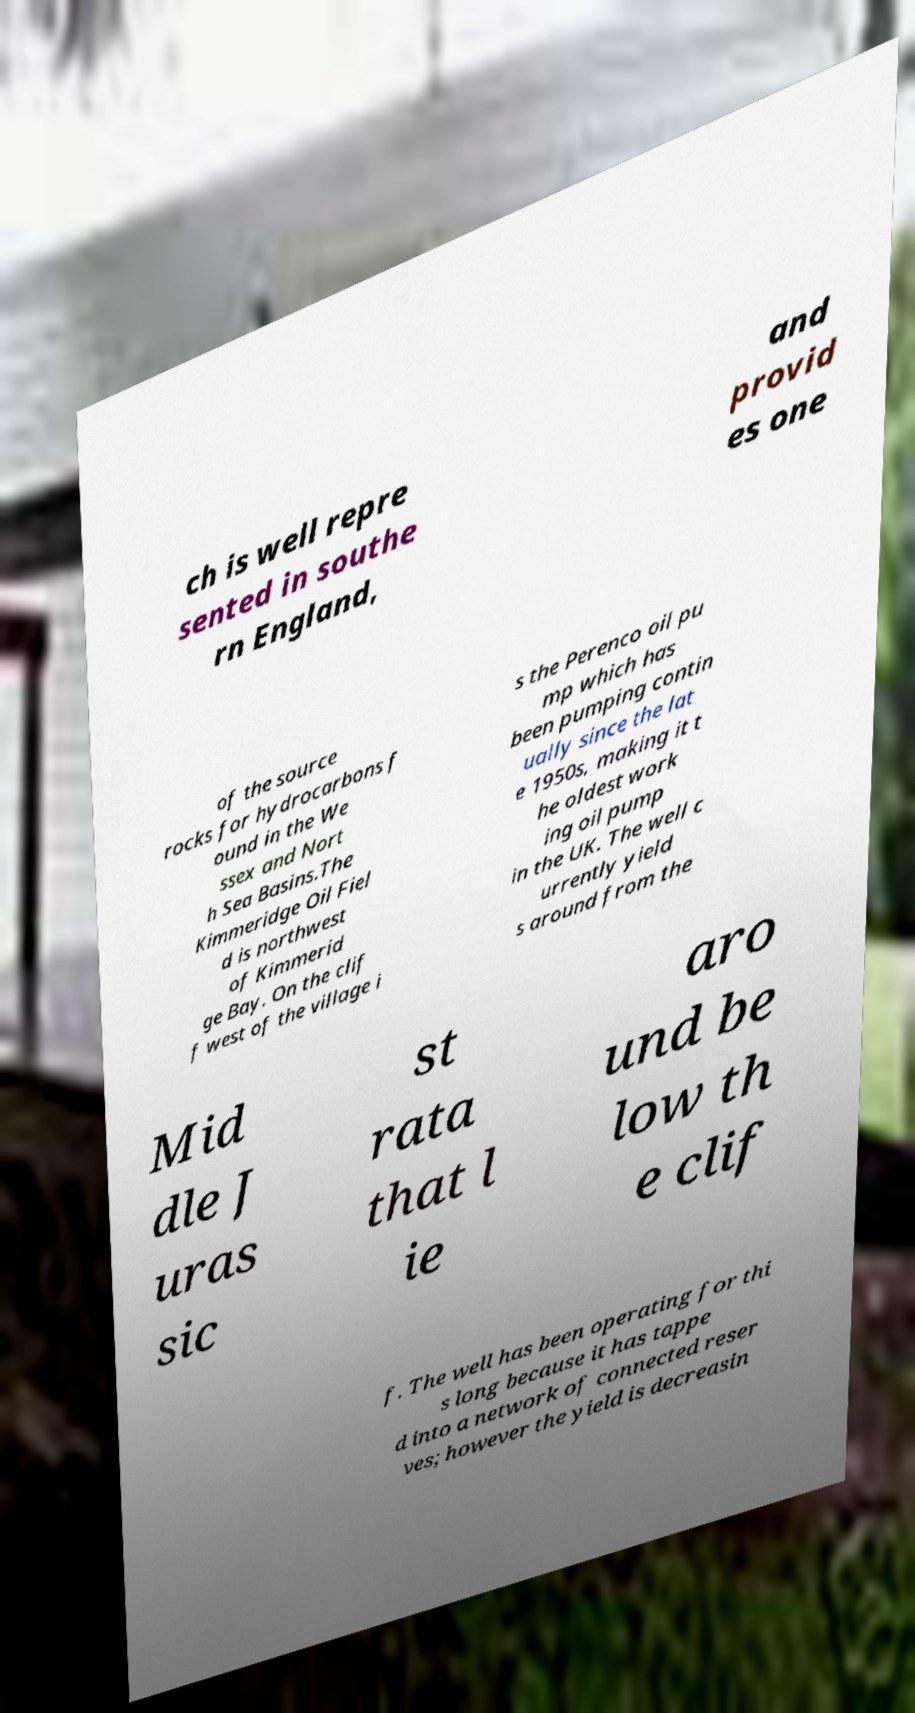Please identify and transcribe the text found in this image. ch is well repre sented in southe rn England, and provid es one of the source rocks for hydrocarbons f ound in the We ssex and Nort h Sea Basins.The Kimmeridge Oil Fiel d is northwest of Kimmerid ge Bay. On the clif f west of the village i s the Perenco oil pu mp which has been pumping contin ually since the lat e 1950s, making it t he oldest work ing oil pump in the UK. The well c urrently yield s around from the Mid dle J uras sic st rata that l ie aro und be low th e clif f. The well has been operating for thi s long because it has tappe d into a network of connected reser ves; however the yield is decreasin 